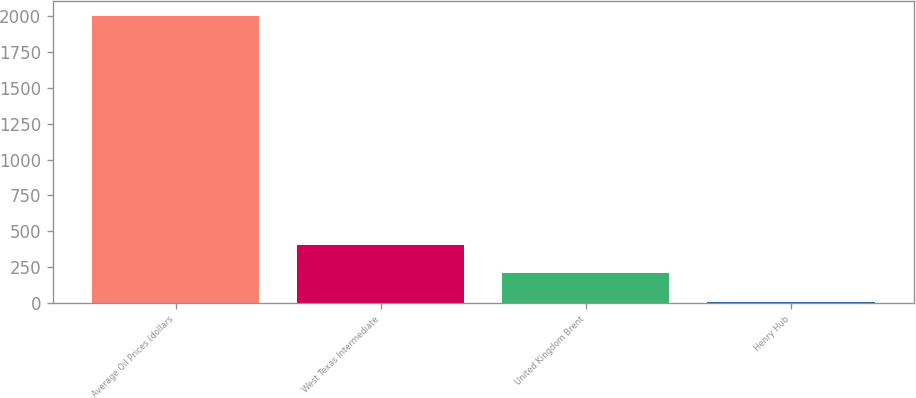Convert chart to OTSL. <chart><loc_0><loc_0><loc_500><loc_500><bar_chart><fcel>Average Oil Prices (dollars<fcel>West Texas Intermediate<fcel>United Kingdom Brent<fcel>Henry Hub<nl><fcel>2006<fcel>406.65<fcel>206.73<fcel>6.81<nl></chart> 